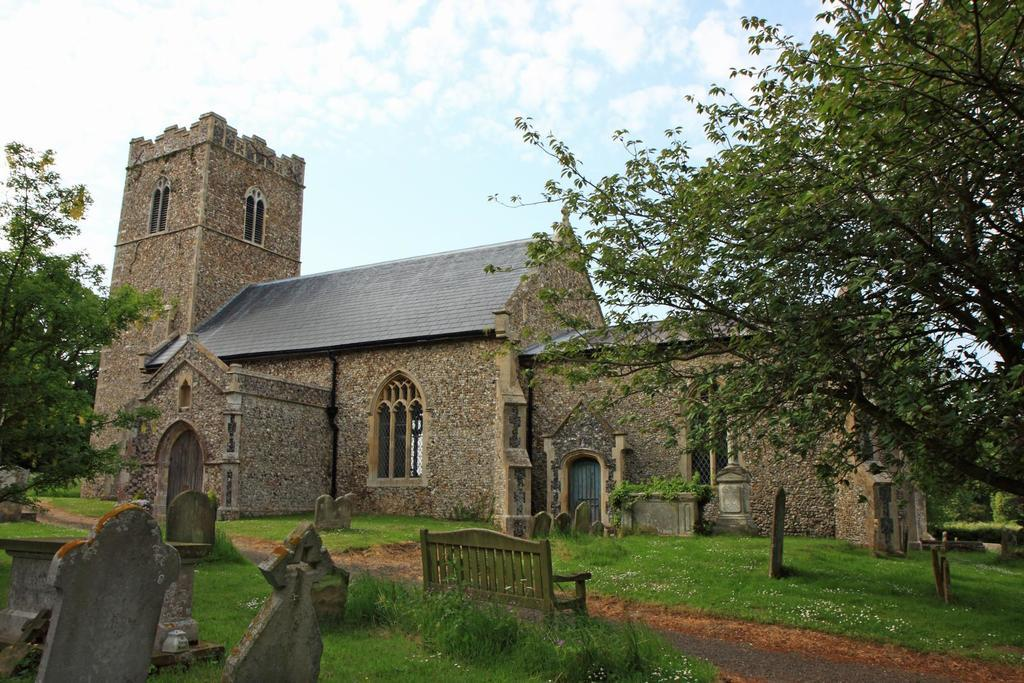What type of structure is visible in the image? There is a building in the image. What can be seen on the ground in the image? There is grass on the floor in the image. What type of path is present in the image? There is a walkway in the image. What type of markers are present in the image? There are grave stones in the image. What type of vegetation is present on both sides of the image? There are trees on the left and right side of the image. What is the condition of the sky in the image? The sky is clear in the image. What type of record can be seen spinning on a turntable in the image? There is no record or turntable present in the image. What type of star is visible in the sky in the image? The sky is clear in the image, but there are no stars visible. 